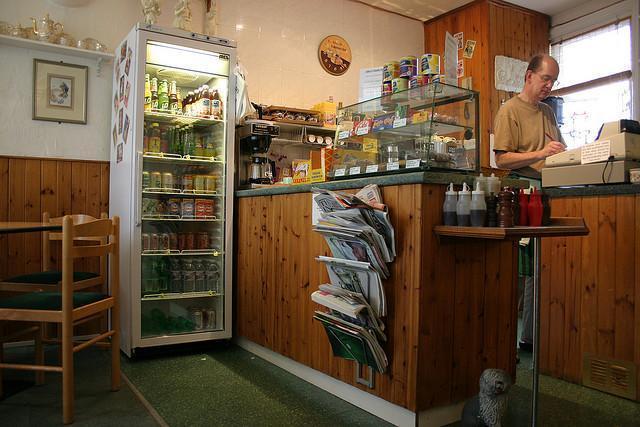What is likely sold here?
Pick the right solution, then justify: 'Answer: answer
Rationale: rationale.'
Options: Video games, action figures, newspaper, model airplanes. Answer: newspaper.
Rationale: Newspapers are the only item listed that are visible in this image and likely for sale. 